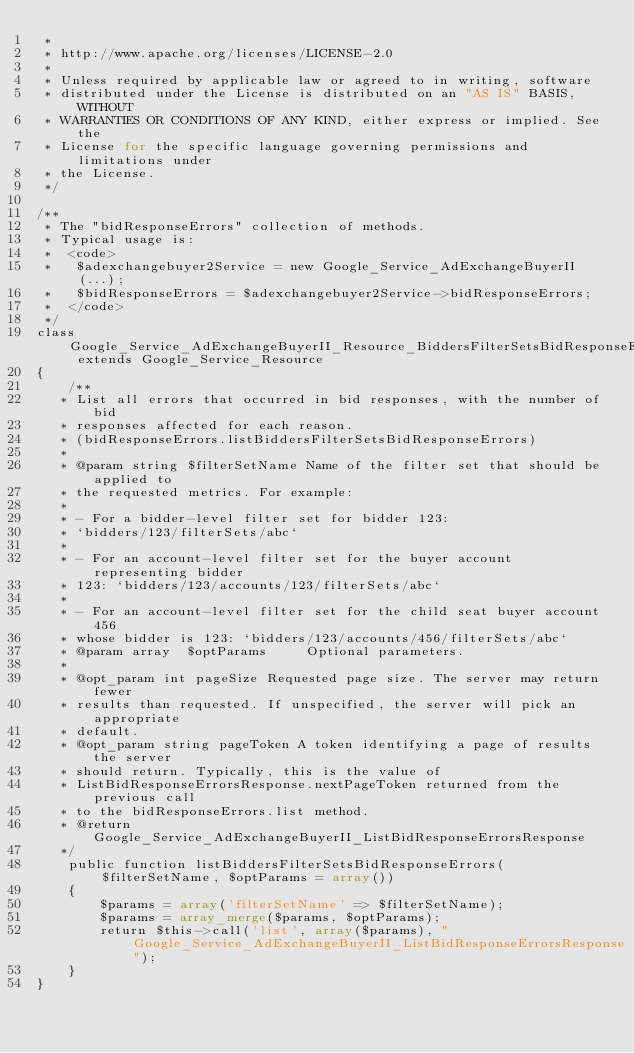Convert code to text. <code><loc_0><loc_0><loc_500><loc_500><_PHP_> *
 * http://www.apache.org/licenses/LICENSE-2.0
 *
 * Unless required by applicable law or agreed to in writing, software
 * distributed under the License is distributed on an "AS IS" BASIS, WITHOUT
 * WARRANTIES OR CONDITIONS OF ANY KIND, either express or implied. See the
 * License for the specific language governing permissions and limitations under
 * the License.
 */

/**
 * The "bidResponseErrors" collection of methods.
 * Typical usage is:
 *  <code>
 *   $adexchangebuyer2Service = new Google_Service_AdExchangeBuyerII(...);
 *   $bidResponseErrors = $adexchangebuyer2Service->bidResponseErrors;
 *  </code>
 */
class Google_Service_AdExchangeBuyerII_Resource_BiddersFilterSetsBidResponseErrors extends Google_Service_Resource
{
    /**
   * List all errors that occurred in bid responses, with the number of bid
   * responses affected for each reason.
   * (bidResponseErrors.listBiddersFilterSetsBidResponseErrors)
   *
   * @param string $filterSetName Name of the filter set that should be applied to
   * the requested metrics. For example:
   *
   * - For a bidder-level filter set for bidder 123:
   * `bidders/123/filterSets/abc`
   *
   * - For an account-level filter set for the buyer account representing bidder
   * 123: `bidders/123/accounts/123/filterSets/abc`
   *
   * - For an account-level filter set for the child seat buyer account 456
   * whose bidder is 123: `bidders/123/accounts/456/filterSets/abc`
   * @param array  $optParams     Optional parameters.
   *
   * @opt_param int pageSize Requested page size. The server may return fewer
   * results than requested. If unspecified, the server will pick an appropriate
   * default.
   * @opt_param string pageToken A token identifying a page of results the server
   * should return. Typically, this is the value of
   * ListBidResponseErrorsResponse.nextPageToken returned from the previous call
   * to the bidResponseErrors.list method.
   * @return    Google_Service_AdExchangeBuyerII_ListBidResponseErrorsResponse
   */
    public function listBiddersFilterSetsBidResponseErrors($filterSetName, $optParams = array())
    {
        $params = array('filterSetName' => $filterSetName);
        $params = array_merge($params, $optParams);
        return $this->call('list', array($params), "Google_Service_AdExchangeBuyerII_ListBidResponseErrorsResponse");
    }
}
</code> 